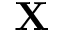<formula> <loc_0><loc_0><loc_500><loc_500>X</formula> 